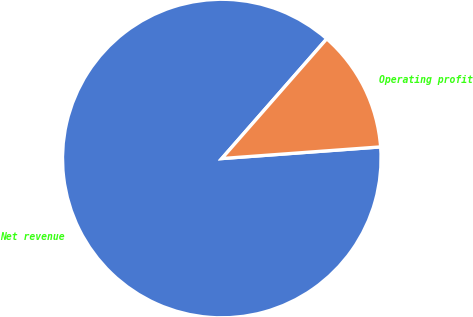<chart> <loc_0><loc_0><loc_500><loc_500><pie_chart><fcel>Net revenue<fcel>Operating profit<nl><fcel>87.62%<fcel>12.38%<nl></chart> 